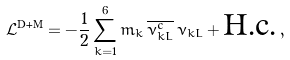<formula> <loc_0><loc_0><loc_500><loc_500>\mathcal { L } ^ { \text {D+M} } = - \frac { 1 } { 2 } \sum _ { k = 1 } ^ { 6 } m _ { k } \, \overline { \nu _ { k L } ^ { c } } \, \nu _ { k L } + \text {H.c.} \, ,</formula> 